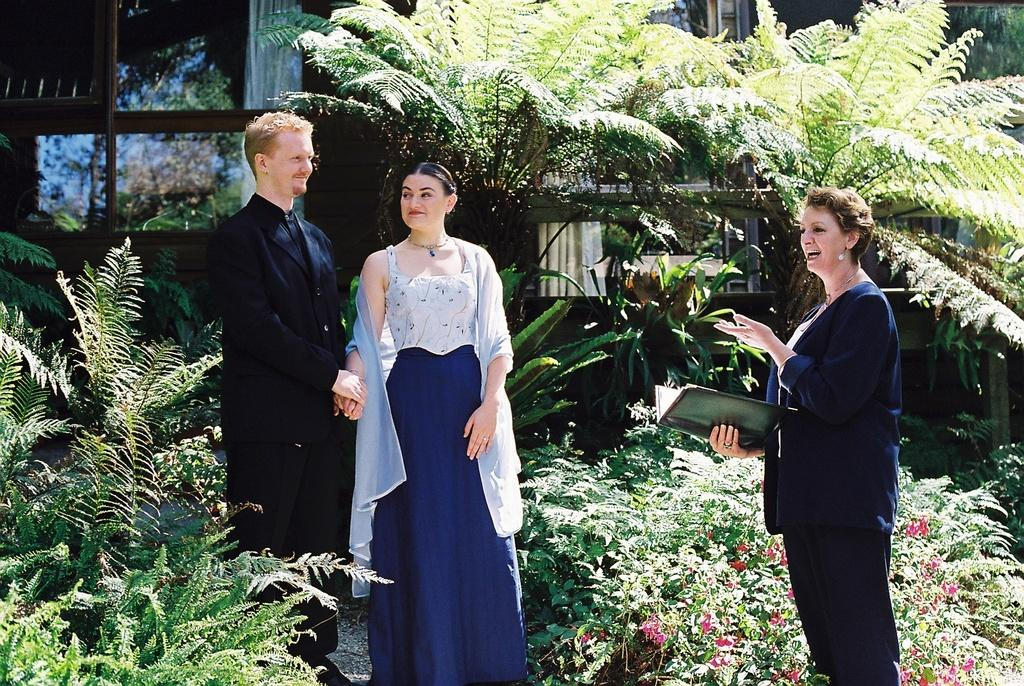How many people are in the image? There are three individuals in the image: one man and two women. What are the people in the image doing? All three individuals are standing and smiling. Can you describe what one of the women is holding? One of the women is holding a file in her hand. What type of vegetation can be seen in the image? There are trees and small plants visible in the image. What kind of structure is visible in the background? The image appears to show a building with glass doors. Is there an island visible in the image? No, there is no island present in the image. What type of coil is being used by the man in the image? There is no coil visible in the image, and the man is not using any coil. 